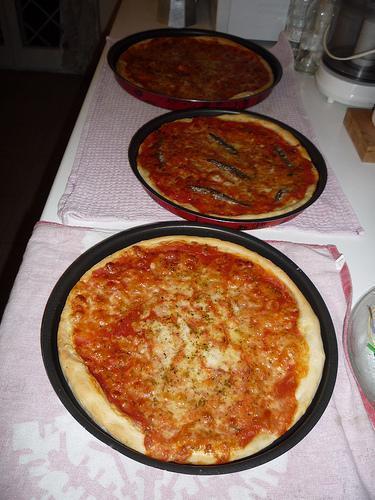How many pizzas?
Give a very brief answer. 3. 